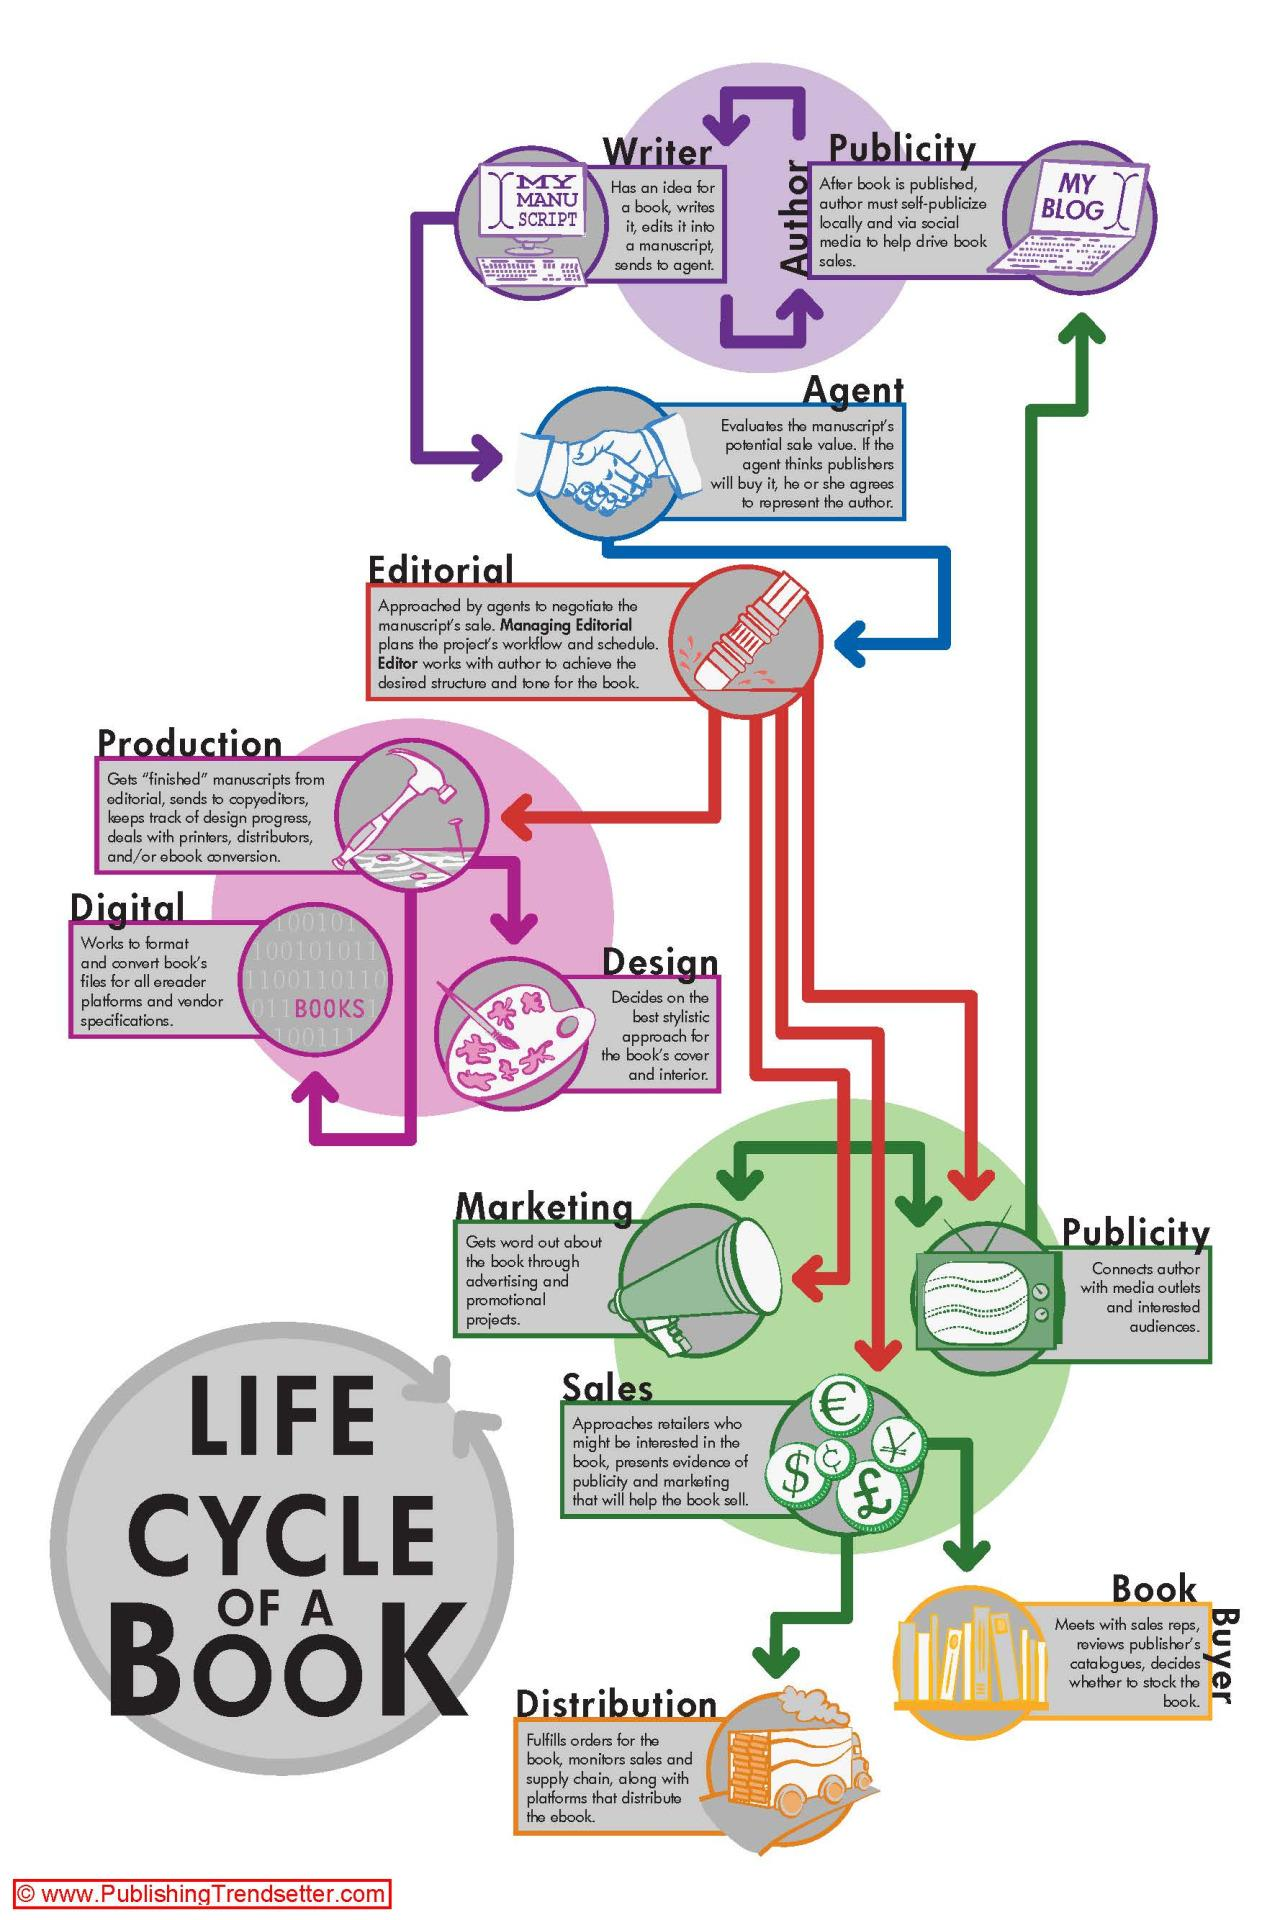Specify some key components in this picture. The agent is the connecting link between the writer and the editorial team. The sales department is the one that connects the editorial and distribution departments. 